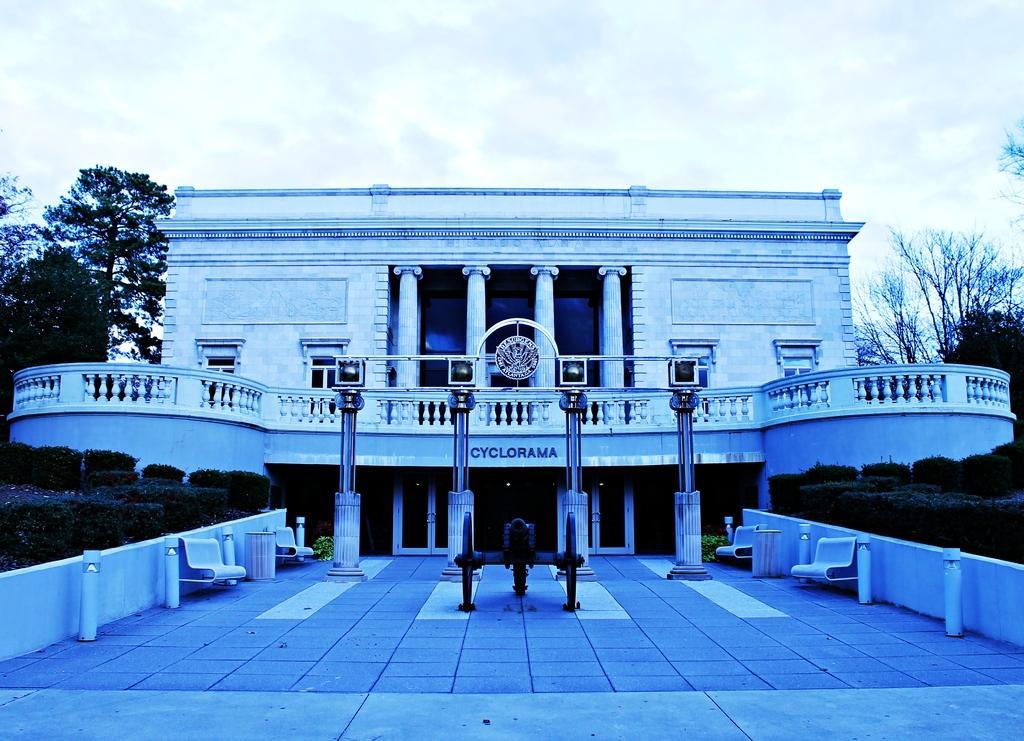How would you summarize this image in a sentence or two? In this image at the center there is a building. On both right and left side of the image there are plants. At the back side there are trees and sky. 